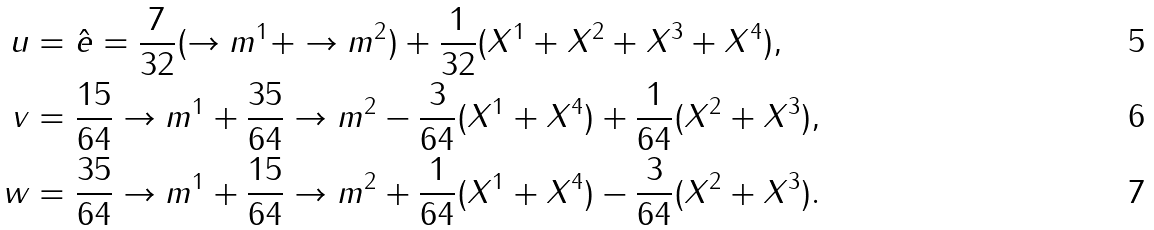Convert formula to latex. <formula><loc_0><loc_0><loc_500><loc_500>u & = \hat { e } = \frac { 7 } { 3 2 } ( \to m ^ { 1 } + \to m ^ { 2 } ) + \frac { 1 } { 3 2 } ( X ^ { 1 } + X ^ { 2 } + X ^ { 3 } + X ^ { 4 } ) , \\ v & = \frac { 1 5 } { 6 4 } \to m ^ { 1 } + \frac { 3 5 } { 6 4 } \to m ^ { 2 } - \frac { 3 } { 6 4 } ( X ^ { 1 } + X ^ { 4 } ) + \frac { 1 } { 6 4 } ( X ^ { 2 } + X ^ { 3 } ) , \\ w & = \frac { 3 5 } { 6 4 } \to m ^ { 1 } + \frac { 1 5 } { 6 4 } \to m ^ { 2 } + \frac { 1 } { 6 4 } ( X ^ { 1 } + X ^ { 4 } ) - \frac { 3 } { 6 4 } ( X ^ { 2 } + X ^ { 3 } ) .</formula> 